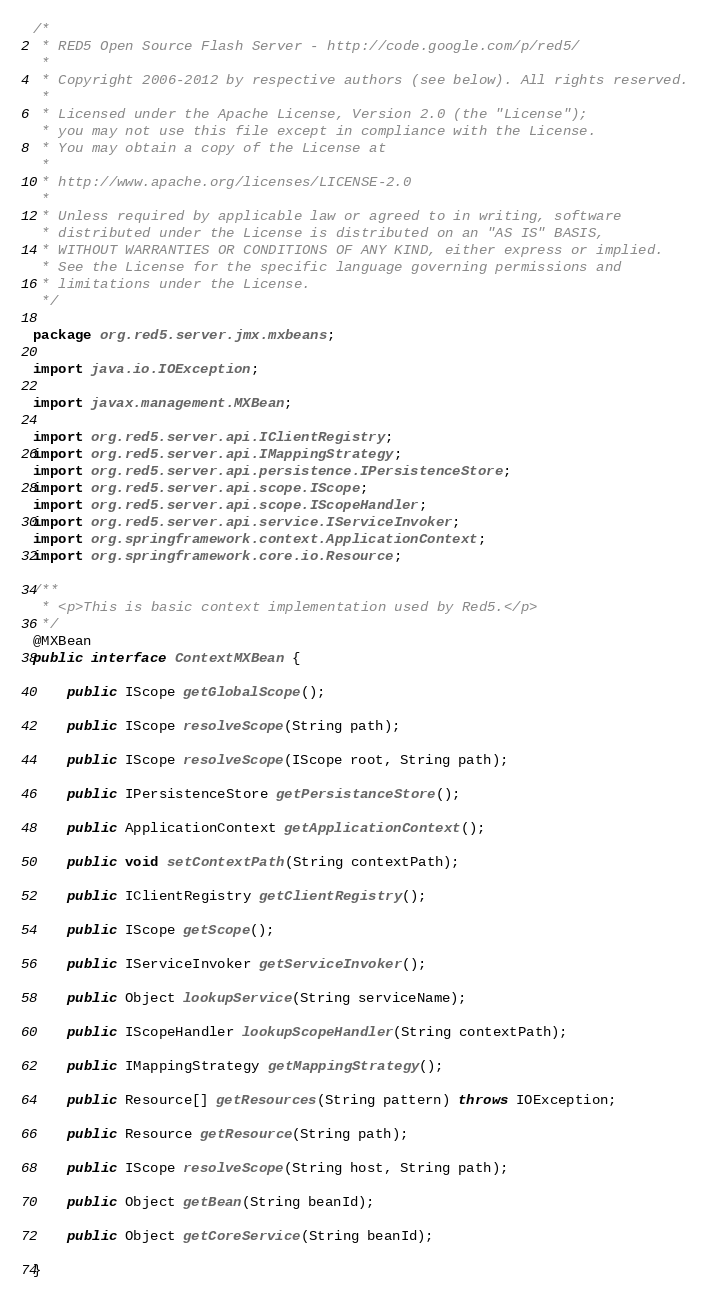Convert code to text. <code><loc_0><loc_0><loc_500><loc_500><_Java_>/*
 * RED5 Open Source Flash Server - http://code.google.com/p/red5/
 * 
 * Copyright 2006-2012 by respective authors (see below). All rights reserved.
 * 
 * Licensed under the Apache License, Version 2.0 (the "License");
 * you may not use this file except in compliance with the License.
 * You may obtain a copy of the License at
 * 
 * http://www.apache.org/licenses/LICENSE-2.0
 * 
 * Unless required by applicable law or agreed to in writing, software
 * distributed under the License is distributed on an "AS IS" BASIS,
 * WITHOUT WARRANTIES OR CONDITIONS OF ANY KIND, either express or implied.
 * See the License for the specific language governing permissions and
 * limitations under the License.
 */

package org.red5.server.jmx.mxbeans;

import java.io.IOException;

import javax.management.MXBean;

import org.red5.server.api.IClientRegistry;
import org.red5.server.api.IMappingStrategy;
import org.red5.server.api.persistence.IPersistenceStore;
import org.red5.server.api.scope.IScope;
import org.red5.server.api.scope.IScopeHandler;
import org.red5.server.api.service.IServiceInvoker;
import org.springframework.context.ApplicationContext;
import org.springframework.core.io.Resource;

/**
 * <p>This is basic context implementation used by Red5.</p>
 */
@MXBean
public interface ContextMXBean {

	public IScope getGlobalScope();

	public IScope resolveScope(String path);

	public IScope resolveScope(IScope root, String path);

	public IPersistenceStore getPersistanceStore();

	public ApplicationContext getApplicationContext();

	public void setContextPath(String contextPath);

	public IClientRegistry getClientRegistry();

	public IScope getScope();

	public IServiceInvoker getServiceInvoker();

	public Object lookupService(String serviceName);

	public IScopeHandler lookupScopeHandler(String contextPath);

	public IMappingStrategy getMappingStrategy();

	public Resource[] getResources(String pattern) throws IOException;

	public Resource getResource(String path);

	public IScope resolveScope(String host, String path);

	public Object getBean(String beanId);

	public Object getCoreService(String beanId);

}
</code> 